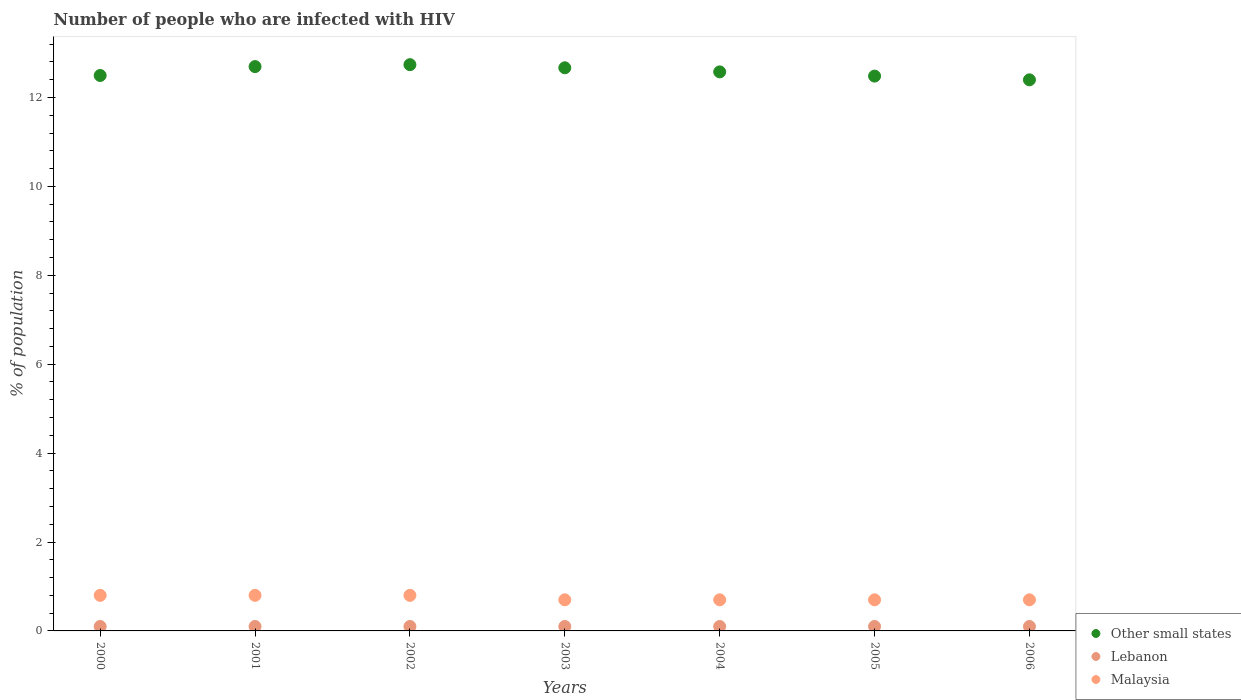Is the number of dotlines equal to the number of legend labels?
Provide a succinct answer. Yes. Across all years, what is the minimum percentage of HIV infected population in in Other small states?
Keep it short and to the point. 12.4. In which year was the percentage of HIV infected population in in Malaysia minimum?
Your response must be concise. 2003. What is the total percentage of HIV infected population in in Malaysia in the graph?
Your response must be concise. 5.2. What is the difference between the percentage of HIV infected population in in Malaysia in 2001 and that in 2002?
Offer a very short reply. 0. What is the difference between the percentage of HIV infected population in in Other small states in 2006 and the percentage of HIV infected population in in Malaysia in 2004?
Provide a succinct answer. 11.7. What is the average percentage of HIV infected population in in Other small states per year?
Provide a succinct answer. 12.58. In the year 2003, what is the difference between the percentage of HIV infected population in in Other small states and percentage of HIV infected population in in Malaysia?
Your answer should be compact. 11.97. What is the ratio of the percentage of HIV infected population in in Lebanon in 2002 to that in 2004?
Make the answer very short. 1. Is the percentage of HIV infected population in in Other small states in 2001 less than that in 2002?
Provide a succinct answer. Yes. What is the difference between the highest and the second highest percentage of HIV infected population in in Other small states?
Give a very brief answer. 0.04. What is the difference between the highest and the lowest percentage of HIV infected population in in Other small states?
Provide a short and direct response. 0.34. In how many years, is the percentage of HIV infected population in in Lebanon greater than the average percentage of HIV infected population in in Lebanon taken over all years?
Offer a very short reply. 7. Is it the case that in every year, the sum of the percentage of HIV infected population in in Malaysia and percentage of HIV infected population in in Other small states  is greater than the percentage of HIV infected population in in Lebanon?
Keep it short and to the point. Yes. Is the percentage of HIV infected population in in Lebanon strictly less than the percentage of HIV infected population in in Other small states over the years?
Make the answer very short. Yes. How many years are there in the graph?
Your answer should be very brief. 7. Are the values on the major ticks of Y-axis written in scientific E-notation?
Your answer should be compact. No. Does the graph contain grids?
Make the answer very short. No. How are the legend labels stacked?
Offer a very short reply. Vertical. What is the title of the graph?
Make the answer very short. Number of people who are infected with HIV. Does "Malaysia" appear as one of the legend labels in the graph?
Give a very brief answer. Yes. What is the label or title of the X-axis?
Your response must be concise. Years. What is the label or title of the Y-axis?
Make the answer very short. % of population. What is the % of population of Other small states in 2000?
Provide a succinct answer. 12.5. What is the % of population of Other small states in 2001?
Offer a terse response. 12.7. What is the % of population of Lebanon in 2001?
Give a very brief answer. 0.1. What is the % of population in Malaysia in 2001?
Offer a terse response. 0.8. What is the % of population of Other small states in 2002?
Offer a very short reply. 12.74. What is the % of population of Lebanon in 2002?
Offer a very short reply. 0.1. What is the % of population in Other small states in 2003?
Offer a terse response. 12.67. What is the % of population in Other small states in 2004?
Keep it short and to the point. 12.58. What is the % of population in Other small states in 2005?
Keep it short and to the point. 12.48. What is the % of population in Malaysia in 2005?
Your answer should be compact. 0.7. What is the % of population of Other small states in 2006?
Make the answer very short. 12.4. What is the % of population in Lebanon in 2006?
Give a very brief answer. 0.1. Across all years, what is the maximum % of population in Other small states?
Keep it short and to the point. 12.74. Across all years, what is the maximum % of population of Malaysia?
Ensure brevity in your answer.  0.8. Across all years, what is the minimum % of population of Other small states?
Provide a short and direct response. 12.4. Across all years, what is the minimum % of population of Lebanon?
Give a very brief answer. 0.1. Across all years, what is the minimum % of population of Malaysia?
Make the answer very short. 0.7. What is the total % of population of Other small states in the graph?
Your response must be concise. 88.05. What is the total % of population in Lebanon in the graph?
Give a very brief answer. 0.7. What is the difference between the % of population of Other small states in 2000 and that in 2001?
Keep it short and to the point. -0.2. What is the difference between the % of population of Other small states in 2000 and that in 2002?
Your answer should be very brief. -0.24. What is the difference between the % of population of Malaysia in 2000 and that in 2002?
Offer a terse response. 0. What is the difference between the % of population of Other small states in 2000 and that in 2003?
Ensure brevity in your answer.  -0.17. What is the difference between the % of population of Malaysia in 2000 and that in 2003?
Ensure brevity in your answer.  0.1. What is the difference between the % of population of Other small states in 2000 and that in 2004?
Ensure brevity in your answer.  -0.08. What is the difference between the % of population of Lebanon in 2000 and that in 2004?
Your answer should be compact. 0. What is the difference between the % of population of Other small states in 2000 and that in 2005?
Provide a succinct answer. 0.01. What is the difference between the % of population of Lebanon in 2000 and that in 2005?
Give a very brief answer. 0. What is the difference between the % of population in Other small states in 2000 and that in 2006?
Ensure brevity in your answer.  0.1. What is the difference between the % of population of Lebanon in 2000 and that in 2006?
Your answer should be compact. 0. What is the difference between the % of population in Other small states in 2001 and that in 2002?
Your response must be concise. -0.04. What is the difference between the % of population in Malaysia in 2001 and that in 2002?
Offer a terse response. 0. What is the difference between the % of population of Other small states in 2001 and that in 2003?
Keep it short and to the point. 0.03. What is the difference between the % of population of Other small states in 2001 and that in 2004?
Offer a terse response. 0.12. What is the difference between the % of population of Other small states in 2001 and that in 2005?
Your response must be concise. 0.21. What is the difference between the % of population in Malaysia in 2001 and that in 2005?
Your response must be concise. 0.1. What is the difference between the % of population of Other small states in 2001 and that in 2006?
Offer a very short reply. 0.3. What is the difference between the % of population of Other small states in 2002 and that in 2003?
Ensure brevity in your answer.  0.07. What is the difference between the % of population of Malaysia in 2002 and that in 2003?
Give a very brief answer. 0.1. What is the difference between the % of population in Other small states in 2002 and that in 2004?
Your response must be concise. 0.16. What is the difference between the % of population of Lebanon in 2002 and that in 2004?
Keep it short and to the point. 0. What is the difference between the % of population of Malaysia in 2002 and that in 2004?
Keep it short and to the point. 0.1. What is the difference between the % of population in Other small states in 2002 and that in 2005?
Offer a very short reply. 0.26. What is the difference between the % of population of Lebanon in 2002 and that in 2005?
Offer a very short reply. 0. What is the difference between the % of population of Other small states in 2002 and that in 2006?
Your response must be concise. 0.34. What is the difference between the % of population in Lebanon in 2002 and that in 2006?
Keep it short and to the point. 0. What is the difference between the % of population of Malaysia in 2002 and that in 2006?
Ensure brevity in your answer.  0.1. What is the difference between the % of population in Other small states in 2003 and that in 2004?
Your answer should be very brief. 0.09. What is the difference between the % of population of Malaysia in 2003 and that in 2004?
Provide a short and direct response. 0. What is the difference between the % of population of Other small states in 2003 and that in 2005?
Provide a short and direct response. 0.19. What is the difference between the % of population in Malaysia in 2003 and that in 2005?
Provide a short and direct response. 0. What is the difference between the % of population in Other small states in 2003 and that in 2006?
Your answer should be compact. 0.27. What is the difference between the % of population of Lebanon in 2003 and that in 2006?
Offer a very short reply. 0. What is the difference between the % of population in Malaysia in 2003 and that in 2006?
Provide a succinct answer. 0. What is the difference between the % of population of Other small states in 2004 and that in 2005?
Your response must be concise. 0.09. What is the difference between the % of population of Lebanon in 2004 and that in 2005?
Provide a succinct answer. 0. What is the difference between the % of population in Malaysia in 2004 and that in 2005?
Offer a terse response. 0. What is the difference between the % of population of Other small states in 2004 and that in 2006?
Your response must be concise. 0.18. What is the difference between the % of population in Malaysia in 2004 and that in 2006?
Offer a terse response. 0. What is the difference between the % of population of Other small states in 2005 and that in 2006?
Your answer should be compact. 0.08. What is the difference between the % of population in Lebanon in 2005 and that in 2006?
Make the answer very short. 0. What is the difference between the % of population of Other small states in 2000 and the % of population of Lebanon in 2001?
Keep it short and to the point. 12.4. What is the difference between the % of population in Other small states in 2000 and the % of population in Malaysia in 2001?
Your response must be concise. 11.7. What is the difference between the % of population of Lebanon in 2000 and the % of population of Malaysia in 2001?
Make the answer very short. -0.7. What is the difference between the % of population in Other small states in 2000 and the % of population in Lebanon in 2002?
Keep it short and to the point. 12.4. What is the difference between the % of population of Other small states in 2000 and the % of population of Malaysia in 2002?
Give a very brief answer. 11.7. What is the difference between the % of population of Lebanon in 2000 and the % of population of Malaysia in 2002?
Your response must be concise. -0.7. What is the difference between the % of population in Other small states in 2000 and the % of population in Lebanon in 2003?
Provide a short and direct response. 12.4. What is the difference between the % of population in Other small states in 2000 and the % of population in Malaysia in 2003?
Your response must be concise. 11.8. What is the difference between the % of population of Other small states in 2000 and the % of population of Lebanon in 2004?
Your answer should be very brief. 12.4. What is the difference between the % of population of Other small states in 2000 and the % of population of Malaysia in 2004?
Offer a very short reply. 11.8. What is the difference between the % of population of Other small states in 2000 and the % of population of Lebanon in 2005?
Offer a very short reply. 12.4. What is the difference between the % of population of Other small states in 2000 and the % of population of Malaysia in 2005?
Offer a very short reply. 11.8. What is the difference between the % of population of Lebanon in 2000 and the % of population of Malaysia in 2005?
Offer a very short reply. -0.6. What is the difference between the % of population in Other small states in 2000 and the % of population in Lebanon in 2006?
Offer a terse response. 12.4. What is the difference between the % of population in Other small states in 2000 and the % of population in Malaysia in 2006?
Your answer should be compact. 11.8. What is the difference between the % of population of Lebanon in 2000 and the % of population of Malaysia in 2006?
Your answer should be compact. -0.6. What is the difference between the % of population of Other small states in 2001 and the % of population of Lebanon in 2002?
Your answer should be compact. 12.6. What is the difference between the % of population of Other small states in 2001 and the % of population of Malaysia in 2002?
Make the answer very short. 11.9. What is the difference between the % of population of Lebanon in 2001 and the % of population of Malaysia in 2002?
Provide a succinct answer. -0.7. What is the difference between the % of population in Other small states in 2001 and the % of population in Lebanon in 2003?
Your answer should be compact. 12.6. What is the difference between the % of population in Other small states in 2001 and the % of population in Malaysia in 2003?
Make the answer very short. 12. What is the difference between the % of population in Lebanon in 2001 and the % of population in Malaysia in 2003?
Your response must be concise. -0.6. What is the difference between the % of population of Other small states in 2001 and the % of population of Lebanon in 2004?
Your answer should be compact. 12.6. What is the difference between the % of population in Other small states in 2001 and the % of population in Malaysia in 2004?
Keep it short and to the point. 12. What is the difference between the % of population in Other small states in 2001 and the % of population in Lebanon in 2005?
Your answer should be compact. 12.6. What is the difference between the % of population in Other small states in 2001 and the % of population in Malaysia in 2005?
Your answer should be very brief. 12. What is the difference between the % of population in Other small states in 2001 and the % of population in Lebanon in 2006?
Give a very brief answer. 12.6. What is the difference between the % of population in Other small states in 2001 and the % of population in Malaysia in 2006?
Make the answer very short. 12. What is the difference between the % of population in Other small states in 2002 and the % of population in Lebanon in 2003?
Ensure brevity in your answer.  12.64. What is the difference between the % of population in Other small states in 2002 and the % of population in Malaysia in 2003?
Keep it short and to the point. 12.04. What is the difference between the % of population of Lebanon in 2002 and the % of population of Malaysia in 2003?
Provide a succinct answer. -0.6. What is the difference between the % of population in Other small states in 2002 and the % of population in Lebanon in 2004?
Your response must be concise. 12.64. What is the difference between the % of population in Other small states in 2002 and the % of population in Malaysia in 2004?
Provide a succinct answer. 12.04. What is the difference between the % of population in Lebanon in 2002 and the % of population in Malaysia in 2004?
Make the answer very short. -0.6. What is the difference between the % of population in Other small states in 2002 and the % of population in Lebanon in 2005?
Offer a very short reply. 12.64. What is the difference between the % of population in Other small states in 2002 and the % of population in Malaysia in 2005?
Make the answer very short. 12.04. What is the difference between the % of population in Lebanon in 2002 and the % of population in Malaysia in 2005?
Your answer should be very brief. -0.6. What is the difference between the % of population of Other small states in 2002 and the % of population of Lebanon in 2006?
Ensure brevity in your answer.  12.64. What is the difference between the % of population of Other small states in 2002 and the % of population of Malaysia in 2006?
Your response must be concise. 12.04. What is the difference between the % of population in Lebanon in 2002 and the % of population in Malaysia in 2006?
Your response must be concise. -0.6. What is the difference between the % of population in Other small states in 2003 and the % of population in Lebanon in 2004?
Your answer should be compact. 12.57. What is the difference between the % of population of Other small states in 2003 and the % of population of Malaysia in 2004?
Offer a very short reply. 11.97. What is the difference between the % of population of Lebanon in 2003 and the % of population of Malaysia in 2004?
Your response must be concise. -0.6. What is the difference between the % of population in Other small states in 2003 and the % of population in Lebanon in 2005?
Provide a short and direct response. 12.57. What is the difference between the % of population in Other small states in 2003 and the % of population in Malaysia in 2005?
Keep it short and to the point. 11.97. What is the difference between the % of population of Lebanon in 2003 and the % of population of Malaysia in 2005?
Keep it short and to the point. -0.6. What is the difference between the % of population of Other small states in 2003 and the % of population of Lebanon in 2006?
Your answer should be compact. 12.57. What is the difference between the % of population of Other small states in 2003 and the % of population of Malaysia in 2006?
Your answer should be very brief. 11.97. What is the difference between the % of population of Other small states in 2004 and the % of population of Lebanon in 2005?
Offer a very short reply. 12.48. What is the difference between the % of population of Other small states in 2004 and the % of population of Malaysia in 2005?
Provide a succinct answer. 11.88. What is the difference between the % of population of Lebanon in 2004 and the % of population of Malaysia in 2005?
Your answer should be very brief. -0.6. What is the difference between the % of population in Other small states in 2004 and the % of population in Lebanon in 2006?
Make the answer very short. 12.48. What is the difference between the % of population in Other small states in 2004 and the % of population in Malaysia in 2006?
Your answer should be very brief. 11.88. What is the difference between the % of population of Lebanon in 2004 and the % of population of Malaysia in 2006?
Make the answer very short. -0.6. What is the difference between the % of population of Other small states in 2005 and the % of population of Lebanon in 2006?
Keep it short and to the point. 12.38. What is the difference between the % of population in Other small states in 2005 and the % of population in Malaysia in 2006?
Ensure brevity in your answer.  11.78. What is the difference between the % of population of Lebanon in 2005 and the % of population of Malaysia in 2006?
Provide a succinct answer. -0.6. What is the average % of population in Other small states per year?
Provide a short and direct response. 12.58. What is the average % of population in Malaysia per year?
Give a very brief answer. 0.74. In the year 2000, what is the difference between the % of population in Other small states and % of population in Lebanon?
Your answer should be compact. 12.4. In the year 2000, what is the difference between the % of population in Other small states and % of population in Malaysia?
Offer a terse response. 11.7. In the year 2001, what is the difference between the % of population of Other small states and % of population of Lebanon?
Your answer should be compact. 12.6. In the year 2001, what is the difference between the % of population in Other small states and % of population in Malaysia?
Offer a very short reply. 11.9. In the year 2002, what is the difference between the % of population in Other small states and % of population in Lebanon?
Your response must be concise. 12.64. In the year 2002, what is the difference between the % of population of Other small states and % of population of Malaysia?
Keep it short and to the point. 11.94. In the year 2002, what is the difference between the % of population of Lebanon and % of population of Malaysia?
Make the answer very short. -0.7. In the year 2003, what is the difference between the % of population in Other small states and % of population in Lebanon?
Your answer should be compact. 12.57. In the year 2003, what is the difference between the % of population in Other small states and % of population in Malaysia?
Ensure brevity in your answer.  11.97. In the year 2003, what is the difference between the % of population of Lebanon and % of population of Malaysia?
Your answer should be very brief. -0.6. In the year 2004, what is the difference between the % of population of Other small states and % of population of Lebanon?
Your answer should be compact. 12.48. In the year 2004, what is the difference between the % of population in Other small states and % of population in Malaysia?
Offer a very short reply. 11.88. In the year 2005, what is the difference between the % of population in Other small states and % of population in Lebanon?
Provide a short and direct response. 12.38. In the year 2005, what is the difference between the % of population in Other small states and % of population in Malaysia?
Keep it short and to the point. 11.78. In the year 2006, what is the difference between the % of population of Other small states and % of population of Lebanon?
Give a very brief answer. 12.3. In the year 2006, what is the difference between the % of population of Other small states and % of population of Malaysia?
Offer a very short reply. 11.7. In the year 2006, what is the difference between the % of population in Lebanon and % of population in Malaysia?
Keep it short and to the point. -0.6. What is the ratio of the % of population of Other small states in 2000 to that in 2001?
Your response must be concise. 0.98. What is the ratio of the % of population of Lebanon in 2000 to that in 2001?
Make the answer very short. 1. What is the ratio of the % of population of Malaysia in 2000 to that in 2001?
Provide a succinct answer. 1. What is the ratio of the % of population of Other small states in 2000 to that in 2002?
Give a very brief answer. 0.98. What is the ratio of the % of population in Other small states in 2000 to that in 2003?
Provide a short and direct response. 0.99. What is the ratio of the % of population of Lebanon in 2000 to that in 2003?
Make the answer very short. 1. What is the ratio of the % of population in Malaysia in 2000 to that in 2004?
Provide a short and direct response. 1.14. What is the ratio of the % of population of Lebanon in 2000 to that in 2005?
Your response must be concise. 1. What is the ratio of the % of population of Other small states in 2000 to that in 2006?
Offer a terse response. 1.01. What is the ratio of the % of population of Lebanon in 2000 to that in 2006?
Offer a very short reply. 1. What is the ratio of the % of population of Malaysia in 2000 to that in 2006?
Your answer should be very brief. 1.14. What is the ratio of the % of population in Lebanon in 2001 to that in 2003?
Your answer should be very brief. 1. What is the ratio of the % of population of Other small states in 2001 to that in 2004?
Make the answer very short. 1.01. What is the ratio of the % of population of Lebanon in 2001 to that in 2004?
Give a very brief answer. 1. What is the ratio of the % of population of Other small states in 2001 to that in 2005?
Keep it short and to the point. 1.02. What is the ratio of the % of population of Lebanon in 2001 to that in 2005?
Make the answer very short. 1. What is the ratio of the % of population in Malaysia in 2001 to that in 2005?
Ensure brevity in your answer.  1.14. What is the ratio of the % of population of Lebanon in 2001 to that in 2006?
Provide a succinct answer. 1. What is the ratio of the % of population in Malaysia in 2001 to that in 2006?
Make the answer very short. 1.14. What is the ratio of the % of population of Other small states in 2002 to that in 2003?
Make the answer very short. 1.01. What is the ratio of the % of population of Lebanon in 2002 to that in 2003?
Your response must be concise. 1. What is the ratio of the % of population of Other small states in 2002 to that in 2004?
Keep it short and to the point. 1.01. What is the ratio of the % of population of Malaysia in 2002 to that in 2004?
Make the answer very short. 1.14. What is the ratio of the % of population in Other small states in 2002 to that in 2005?
Give a very brief answer. 1.02. What is the ratio of the % of population of Other small states in 2002 to that in 2006?
Offer a terse response. 1.03. What is the ratio of the % of population in Malaysia in 2002 to that in 2006?
Your answer should be very brief. 1.14. What is the ratio of the % of population of Other small states in 2003 to that in 2004?
Provide a short and direct response. 1.01. What is the ratio of the % of population in Lebanon in 2003 to that in 2004?
Provide a short and direct response. 1. What is the ratio of the % of population of Malaysia in 2003 to that in 2004?
Your response must be concise. 1. What is the ratio of the % of population in Lebanon in 2003 to that in 2005?
Your answer should be compact. 1. What is the ratio of the % of population of Other small states in 2003 to that in 2006?
Keep it short and to the point. 1.02. What is the ratio of the % of population of Other small states in 2004 to that in 2005?
Provide a succinct answer. 1.01. What is the ratio of the % of population of Other small states in 2004 to that in 2006?
Make the answer very short. 1.01. What is the ratio of the % of population of Lebanon in 2004 to that in 2006?
Keep it short and to the point. 1. What is the ratio of the % of population of Malaysia in 2004 to that in 2006?
Make the answer very short. 1. What is the ratio of the % of population of Other small states in 2005 to that in 2006?
Your answer should be very brief. 1.01. What is the ratio of the % of population of Malaysia in 2005 to that in 2006?
Ensure brevity in your answer.  1. What is the difference between the highest and the second highest % of population in Other small states?
Offer a terse response. 0.04. What is the difference between the highest and the lowest % of population in Other small states?
Ensure brevity in your answer.  0.34. What is the difference between the highest and the lowest % of population in Lebanon?
Your answer should be compact. 0. What is the difference between the highest and the lowest % of population of Malaysia?
Keep it short and to the point. 0.1. 